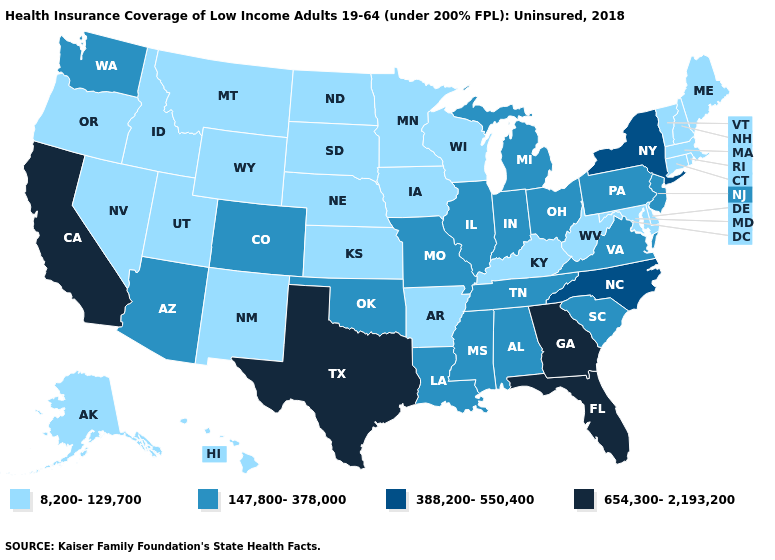What is the value of Nebraska?
Short answer required. 8,200-129,700. Which states hav the highest value in the West?
Be succinct. California. What is the value of Vermont?
Be succinct. 8,200-129,700. Does Arizona have a lower value than Delaware?
Answer briefly. No. What is the highest value in states that border Minnesota?
Short answer required. 8,200-129,700. Name the states that have a value in the range 654,300-2,193,200?
Quick response, please. California, Florida, Georgia, Texas. What is the lowest value in states that border Missouri?
Give a very brief answer. 8,200-129,700. What is the lowest value in the South?
Write a very short answer. 8,200-129,700. Does the map have missing data?
Answer briefly. No. What is the value of Alabama?
Give a very brief answer. 147,800-378,000. Name the states that have a value in the range 8,200-129,700?
Keep it brief. Alaska, Arkansas, Connecticut, Delaware, Hawaii, Idaho, Iowa, Kansas, Kentucky, Maine, Maryland, Massachusetts, Minnesota, Montana, Nebraska, Nevada, New Hampshire, New Mexico, North Dakota, Oregon, Rhode Island, South Dakota, Utah, Vermont, West Virginia, Wisconsin, Wyoming. What is the lowest value in states that border Wyoming?
Quick response, please. 8,200-129,700. What is the lowest value in states that border Washington?
Concise answer only. 8,200-129,700. Among the states that border Iowa , which have the highest value?
Be succinct. Illinois, Missouri. Which states have the lowest value in the MidWest?
Answer briefly. Iowa, Kansas, Minnesota, Nebraska, North Dakota, South Dakota, Wisconsin. 